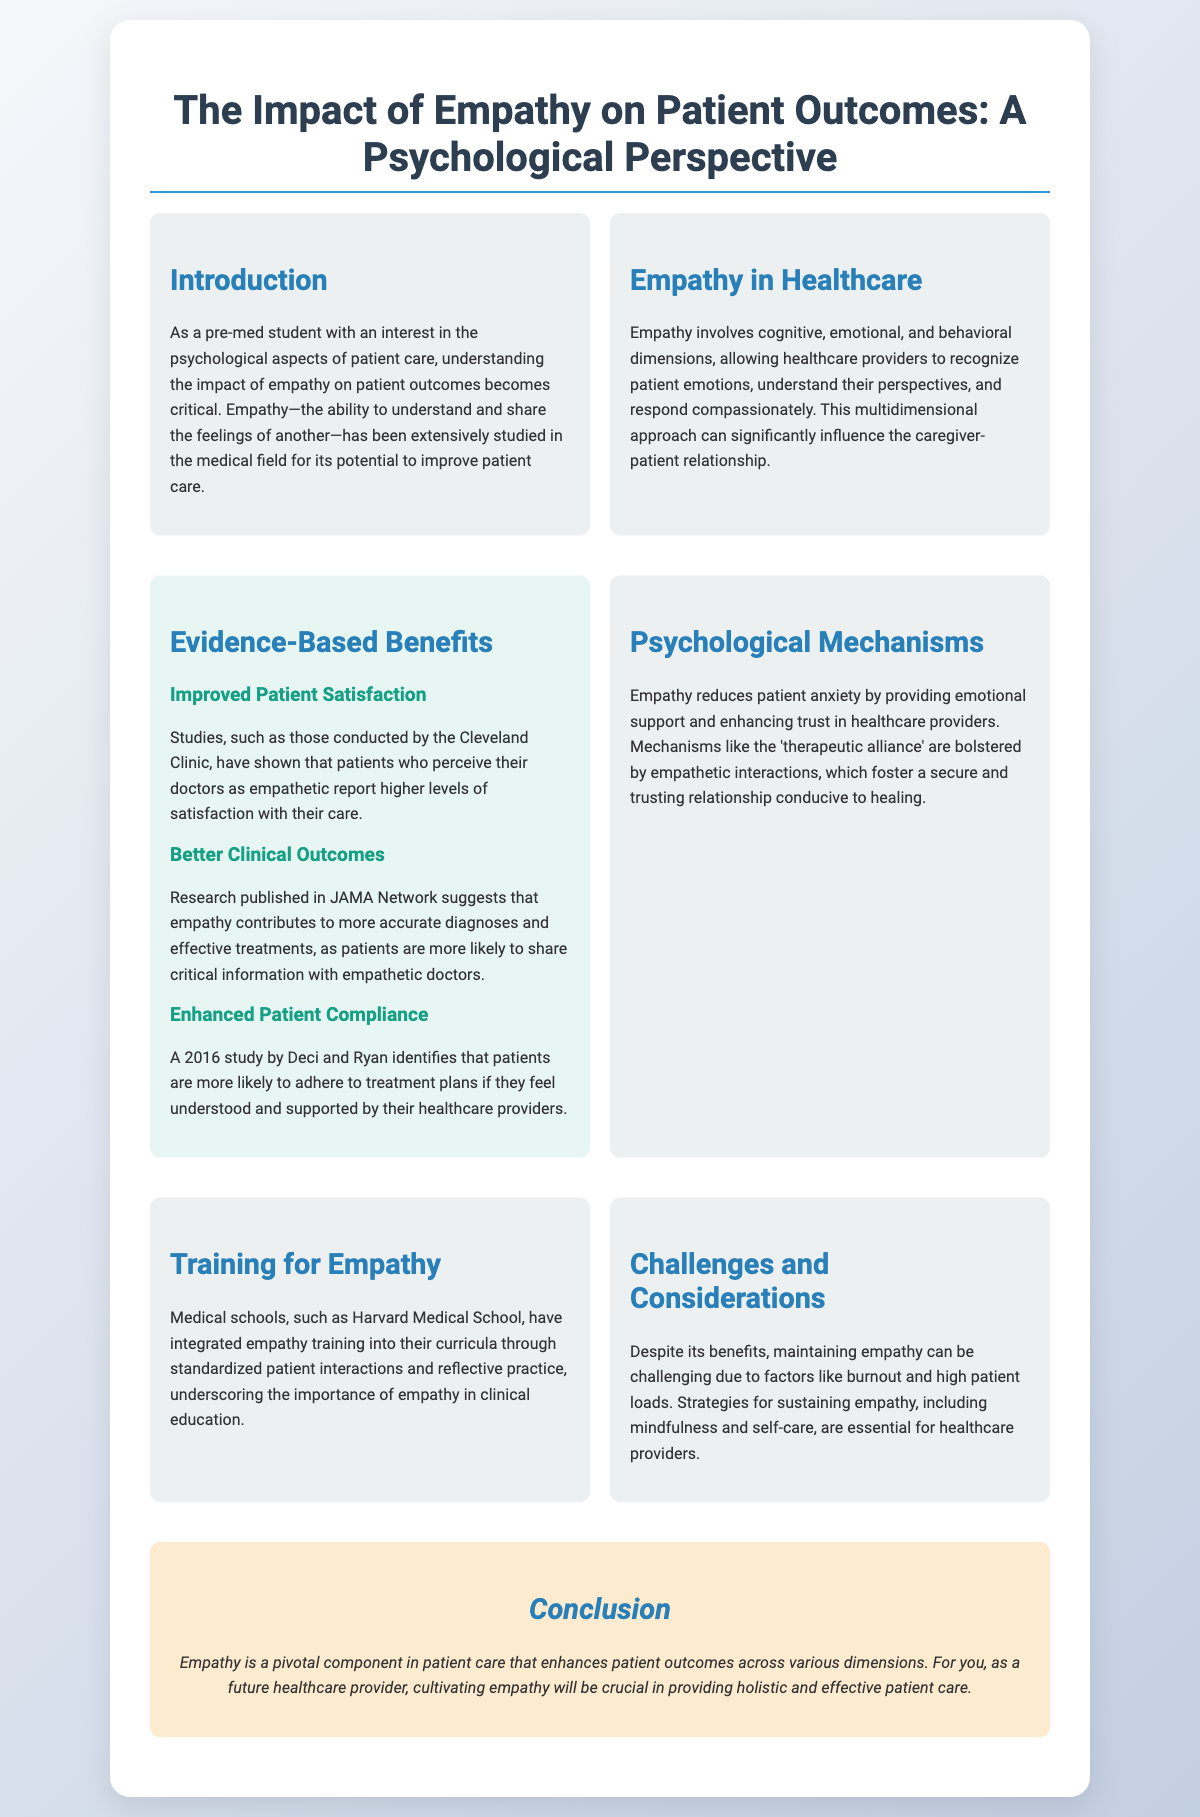what is the title of the presentation? The title is found at the top of the document, summarizing the main topic being discussed.
Answer: The Impact of Empathy on Patient Outcomes: A Psychological Perspective what are the three dimensions of empathy mentioned? The document outlines cognitive, emotional, and behavioral dimensions as the three aspects of empathy in healthcare.
Answer: Cognitive, emotional, and behavioral which institution integrated empathy training into its curriculum? The document specifies that Harvard Medical School has incorporated empathy training in their educational programs.
Answer: Harvard Medical School what benefits are associated with empathy according to JAMA Network? The document states that empathy contributes to more accurate diagnoses and effective treatments as noted in research published in JAMA Network.
Answer: More accurate diagnoses and effective treatments what does the 'therapeutic alliance' refer to? The document implies that the therapeutic alliance is enhanced by empathetic interactions, fostering trust and security in patient-provider relationships.
Answer: Enhanced by empathetic interactions which study identifies that patients are more likely to adhere to treatment plans? The document mentions a 2016 study by Deci and Ryan that highlights the correlation between patient adherence and feeling understood by providers.
Answer: 2016 study by Deci and Ryan what challenges are mentioned that can affect the maintenance of empathy? The document lists burnout and high patient loads as challenges that can hinder empathetic care in healthcare providers.
Answer: Burnout and high patient loads what is the concluding statement of the presentation? The conclusion summarizes the importance of empathy in patient care and its impact on outcomes, which is reiterated at the end of the document.
Answer: Empathy is a pivotal component in patient care that enhances patient outcomes across various dimensions 